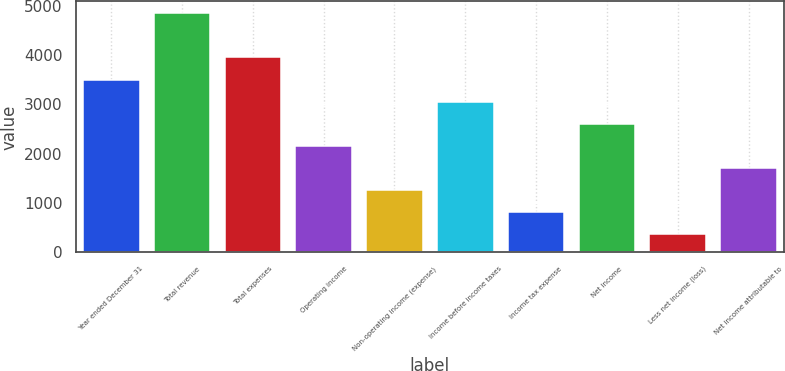Convert chart to OTSL. <chart><loc_0><loc_0><loc_500><loc_500><bar_chart><fcel>Year ended December 31<fcel>Total revenue<fcel>Total expenses<fcel>Operating income<fcel>Non-operating income (expense)<fcel>Income before income taxes<fcel>Income tax expense<fcel>Net income<fcel>Less net income (loss)<fcel>Net income attributable to<nl><fcel>3500.7<fcel>4845<fcel>3948.8<fcel>2156.4<fcel>1260.2<fcel>3052.6<fcel>812.1<fcel>2604.5<fcel>364<fcel>1708.3<nl></chart> 